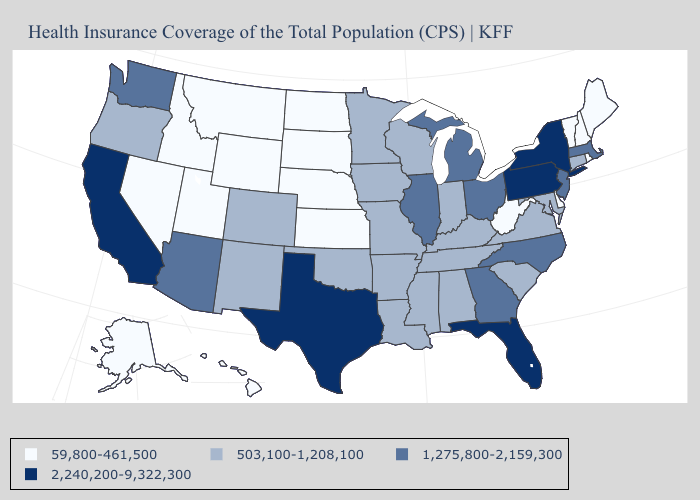Name the states that have a value in the range 503,100-1,208,100?
Quick response, please. Alabama, Arkansas, Colorado, Connecticut, Indiana, Iowa, Kentucky, Louisiana, Maryland, Minnesota, Mississippi, Missouri, New Mexico, Oklahoma, Oregon, South Carolina, Tennessee, Virginia, Wisconsin. Does Idaho have the highest value in the USA?
Be succinct. No. What is the highest value in the USA?
Short answer required. 2,240,200-9,322,300. Name the states that have a value in the range 2,240,200-9,322,300?
Quick response, please. California, Florida, New York, Pennsylvania, Texas. Does the first symbol in the legend represent the smallest category?
Concise answer only. Yes. Among the states that border Wisconsin , does Iowa have the lowest value?
Keep it brief. Yes. What is the lowest value in the West?
Keep it brief. 59,800-461,500. What is the value of Arkansas?
Concise answer only. 503,100-1,208,100. Which states have the lowest value in the USA?
Keep it brief. Alaska, Delaware, Hawaii, Idaho, Kansas, Maine, Montana, Nebraska, Nevada, New Hampshire, North Dakota, Rhode Island, South Dakota, Utah, Vermont, West Virginia, Wyoming. Does New Jersey have the lowest value in the USA?
Quick response, please. No. What is the value of New Jersey?
Give a very brief answer. 1,275,800-2,159,300. What is the value of South Carolina?
Concise answer only. 503,100-1,208,100. Does Massachusetts have the lowest value in the USA?
Answer briefly. No. What is the value of Oregon?
Write a very short answer. 503,100-1,208,100. Does Wisconsin have the lowest value in the MidWest?
Be succinct. No. 